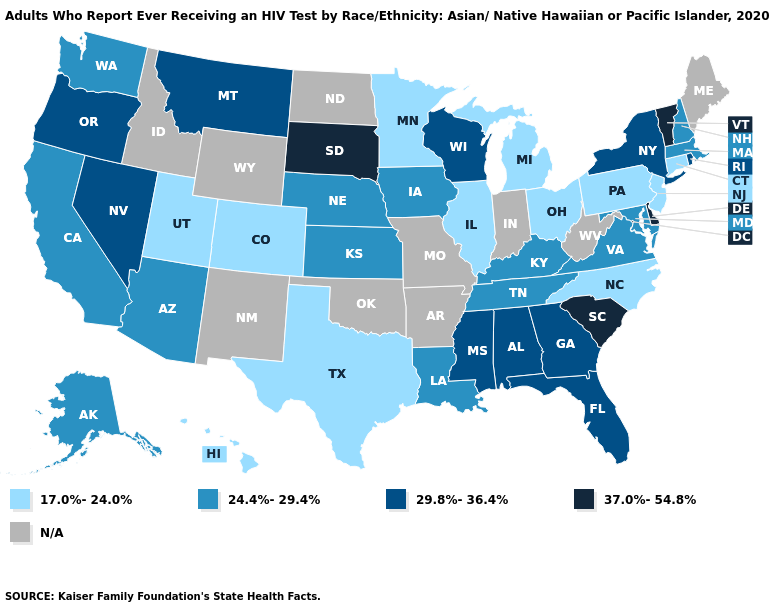Name the states that have a value in the range 24.4%-29.4%?
Short answer required. Alaska, Arizona, California, Iowa, Kansas, Kentucky, Louisiana, Maryland, Massachusetts, Nebraska, New Hampshire, Tennessee, Virginia, Washington. What is the lowest value in the USA?
Concise answer only. 17.0%-24.0%. Among the states that border Missouri , which have the highest value?
Be succinct. Iowa, Kansas, Kentucky, Nebraska, Tennessee. Name the states that have a value in the range 29.8%-36.4%?
Be succinct. Alabama, Florida, Georgia, Mississippi, Montana, Nevada, New York, Oregon, Rhode Island, Wisconsin. Among the states that border Idaho , does Utah have the lowest value?
Concise answer only. Yes. What is the lowest value in states that border Arkansas?
Concise answer only. 17.0%-24.0%. What is the value of Wyoming?
Keep it brief. N/A. Among the states that border Oregon , does Nevada have the highest value?
Short answer required. Yes. Which states have the highest value in the USA?
Short answer required. Delaware, South Carolina, South Dakota, Vermont. What is the highest value in the USA?
Concise answer only. 37.0%-54.8%. Name the states that have a value in the range 24.4%-29.4%?
Write a very short answer. Alaska, Arizona, California, Iowa, Kansas, Kentucky, Louisiana, Maryland, Massachusetts, Nebraska, New Hampshire, Tennessee, Virginia, Washington. 